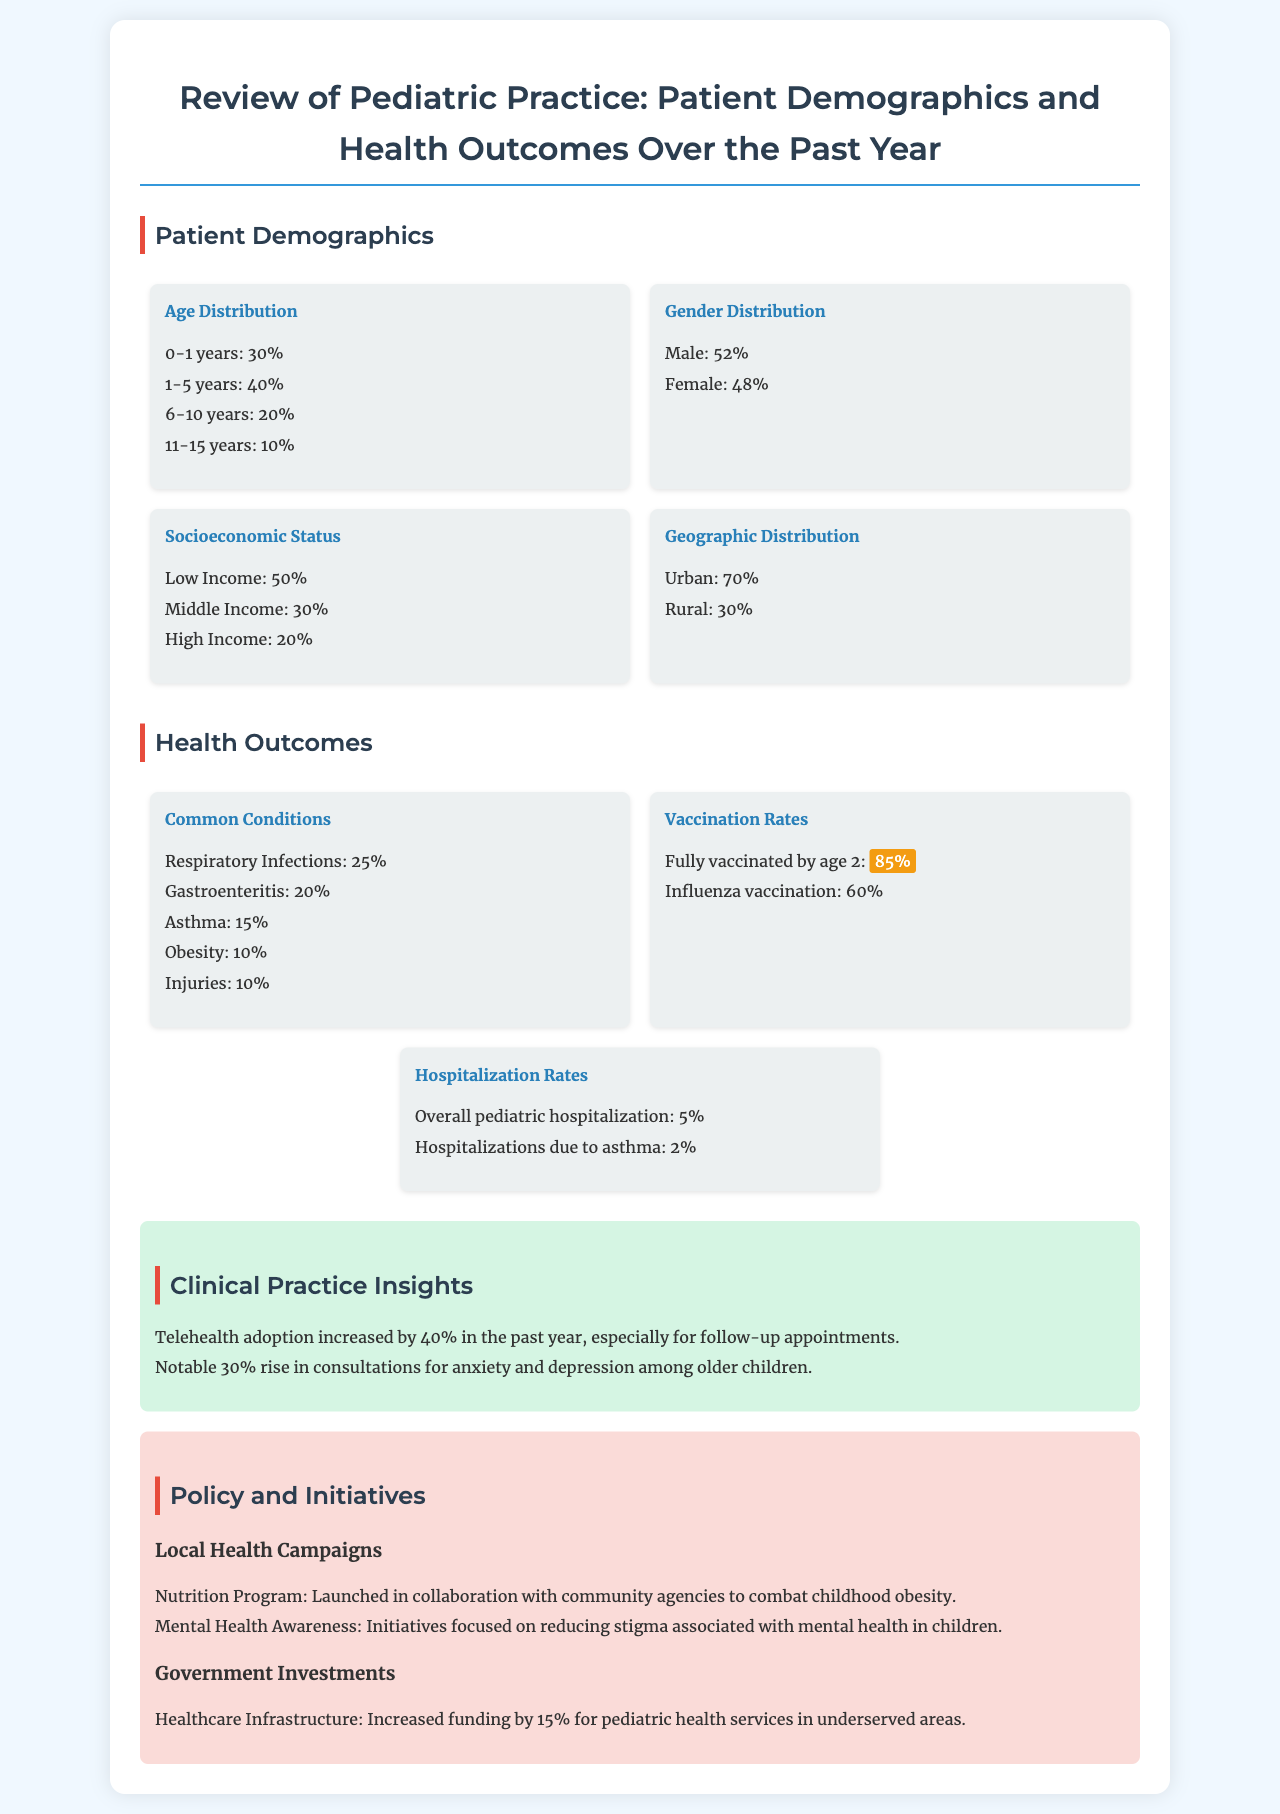What percentage of patients are aged 0-1 years? The report states that 30% of patients fall within the 0-1 years age group.
Answer: 30% What is the overall hospitalization rate for pediatric patients? The document mentions that the overall pediatric hospitalization rate is 5%.
Answer: 5% What condition accounted for 25% of common health issues? Respiratory infections are noted to account for 25% of common conditions.
Answer: Respiratory Infections What percentage of children are fully vaccinated by age 2? The report highlights that 85% of children are fully vaccinated by age 2.
Answer: 85% What is the gender distribution of patients in the practice? The gender distribution shows that 52% are male and 48% are female.
Answer: 52% male, 48% female What increase was noted in telehealth adoption? A significant increase of 40% in telehealth adoption was reported.
Answer: 40% What new program was launched to combat childhood obesity? The Nutrition Program was launched in collaboration with community agencies.
Answer: Nutrition Program What percentage of patients comes from urban areas? The document indicates that 70% of patients are from urban areas.
Answer: 70% What percentage of patients had consultations for anxiety and depression? There was a notable 30% rise in consultations for anxiety and depression among older children.
Answer: 30% 